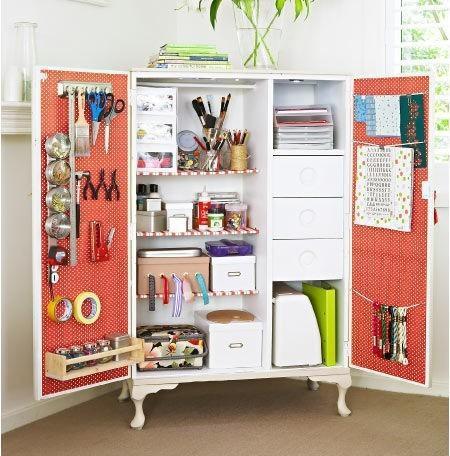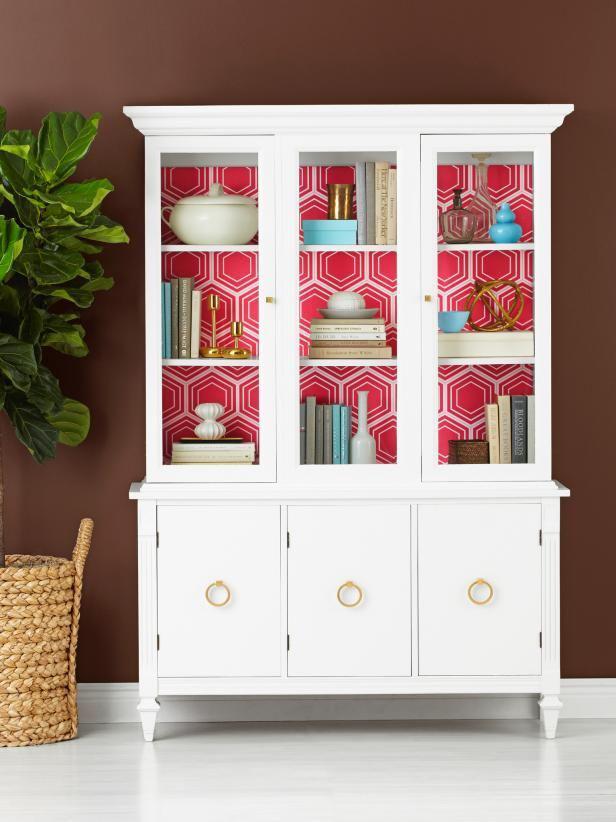The first image is the image on the left, the second image is the image on the right. Analyze the images presented: Is the assertion "None of the cabinets are colored red." valid? Answer yes or no. No. 